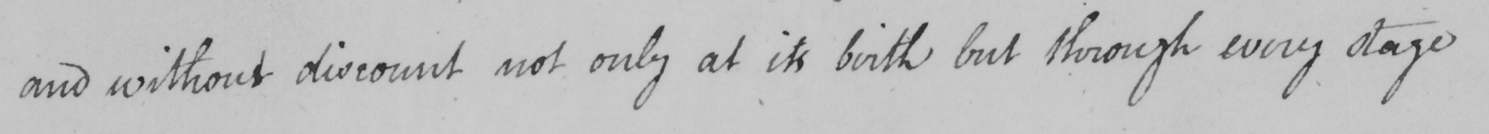Transcribe the text shown in this historical manuscript line. and without discount not only at its birth but through every stage 